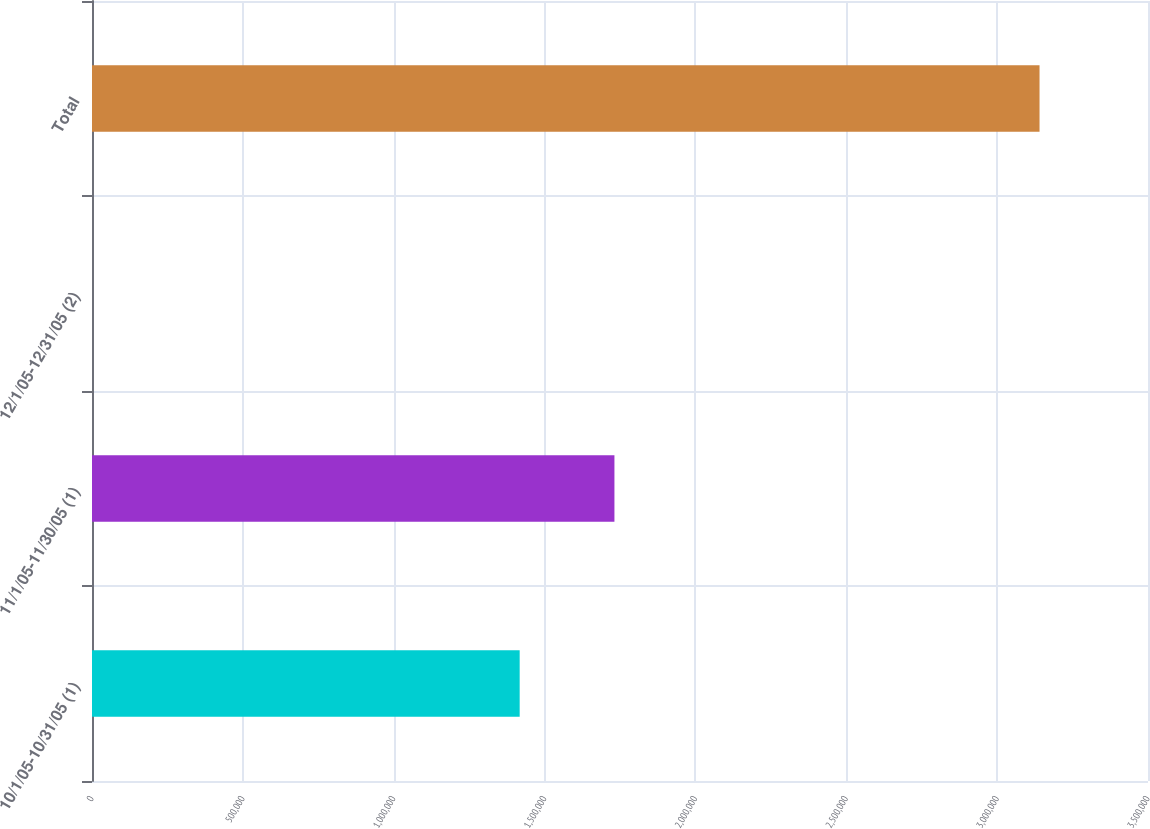<chart> <loc_0><loc_0><loc_500><loc_500><bar_chart><fcel>10/1/05-10/31/05 (1)<fcel>11/1/05-11/30/05 (1)<fcel>12/1/05-12/31/05 (2)<fcel>Total<nl><fcel>1.4175e+06<fcel>1.73155e+06<fcel>0.48<fcel>3.1405e+06<nl></chart> 